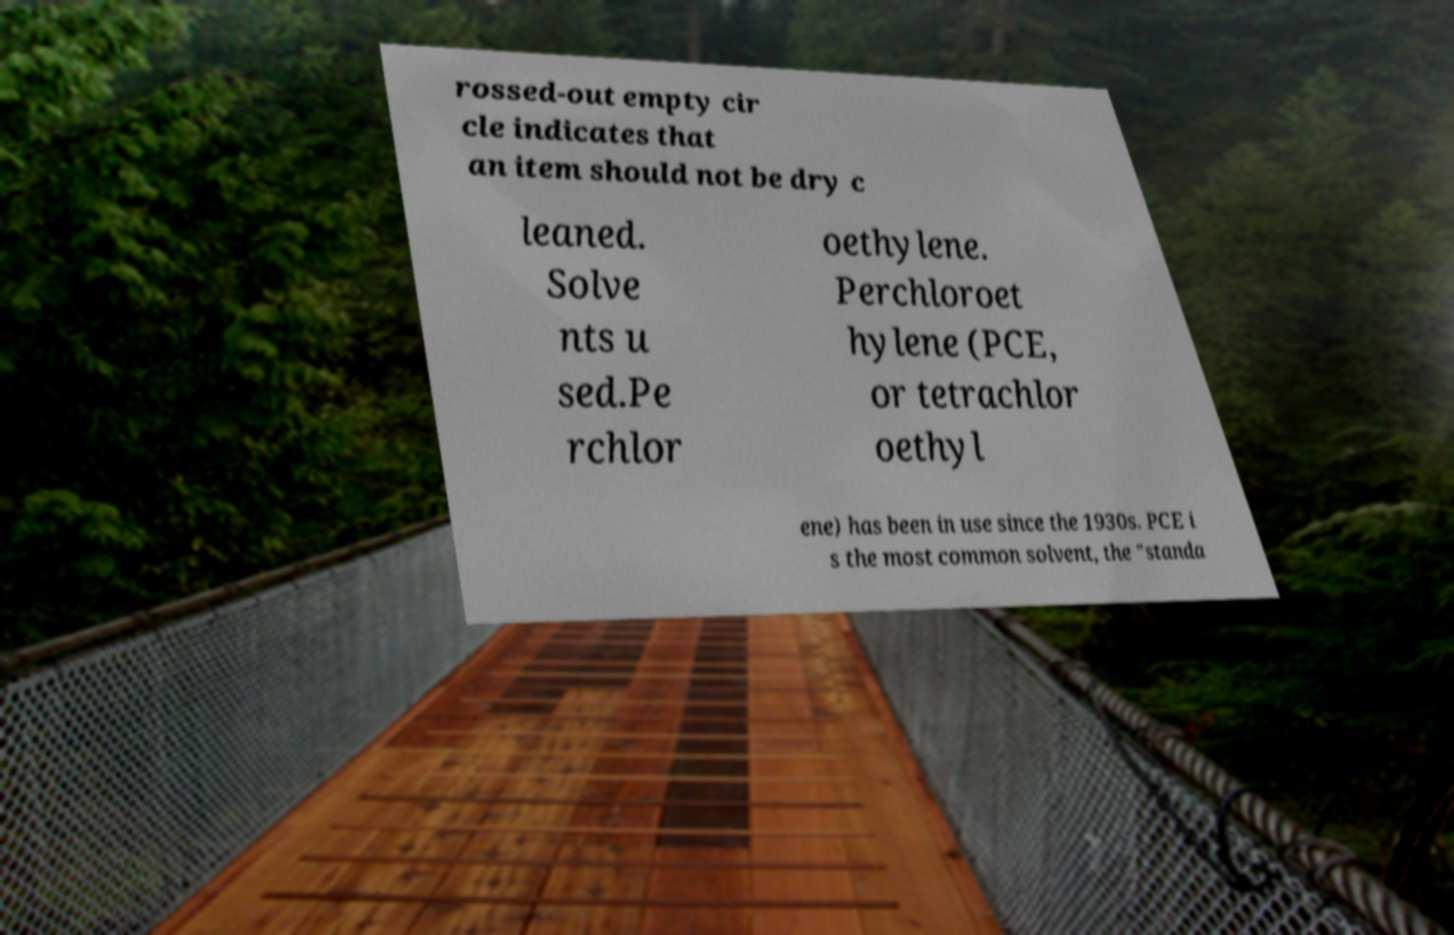Can you accurately transcribe the text from the provided image for me? rossed-out empty cir cle indicates that an item should not be dry c leaned. Solve nts u sed.Pe rchlor oethylene. Perchloroet hylene (PCE, or tetrachlor oethyl ene) has been in use since the 1930s. PCE i s the most common solvent, the "standa 